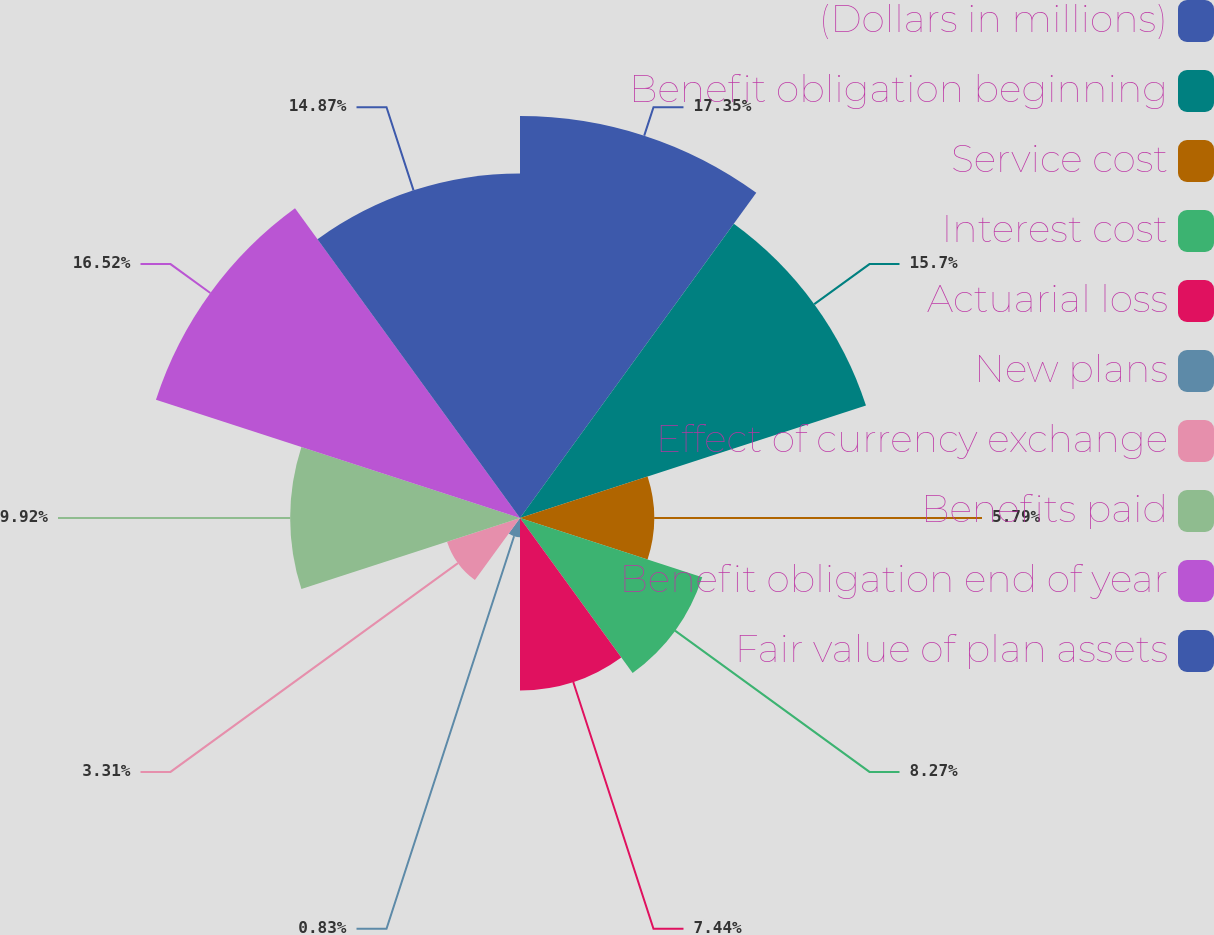<chart> <loc_0><loc_0><loc_500><loc_500><pie_chart><fcel>(Dollars in millions)<fcel>Benefit obligation beginning<fcel>Service cost<fcel>Interest cost<fcel>Actuarial loss<fcel>New plans<fcel>Effect of currency exchange<fcel>Benefits paid<fcel>Benefit obligation end of year<fcel>Fair value of plan assets<nl><fcel>17.35%<fcel>15.7%<fcel>5.79%<fcel>8.27%<fcel>7.44%<fcel>0.83%<fcel>3.31%<fcel>9.92%<fcel>16.52%<fcel>14.87%<nl></chart> 